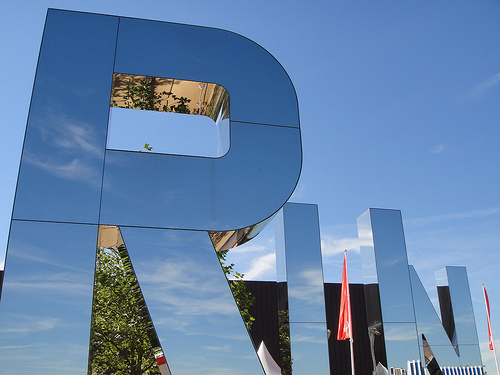<image>
Can you confirm if the tree is under the letter? No. The tree is not positioned under the letter. The vertical relationship between these objects is different. 